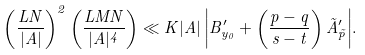<formula> <loc_0><loc_0><loc_500><loc_500>\left ( \frac { L N } { | A | } \right ) ^ { 2 } \left ( \frac { L M N } { | A | ^ { 4 } } \right ) \ll { K | A | \left | B _ { y _ { 0 } } ^ { \prime } + \left ( \frac { p - q } { s - t } \right ) \tilde { A } _ { \tilde { p } } ^ { \prime } \right | } .</formula> 